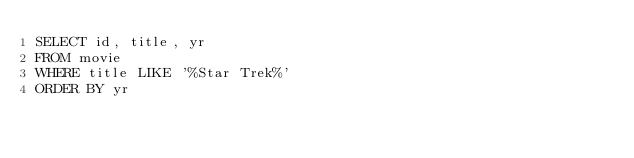Convert code to text. <code><loc_0><loc_0><loc_500><loc_500><_SQL_>SELECT id, title, yr
FROM movie
WHERE title LIKE '%Star Trek%'
ORDER BY yr
</code> 